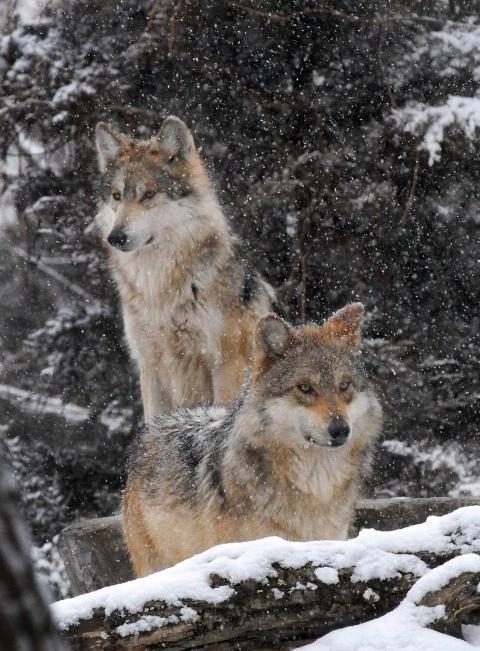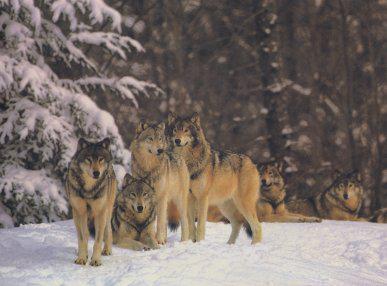The first image is the image on the left, the second image is the image on the right. Assess this claim about the two images: "An image contains exactly two wolves, which are close together in a snowy scene.". Correct or not? Answer yes or no. Yes. The first image is the image on the left, the second image is the image on the right. Examine the images to the left and right. Is the description "The left image contains no more than two wolves." accurate? Answer yes or no. Yes. 